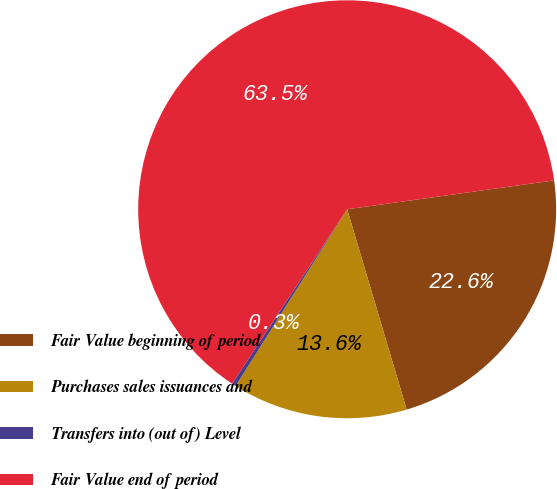Convert chart. <chart><loc_0><loc_0><loc_500><loc_500><pie_chart><fcel>Fair Value beginning of period<fcel>Purchases sales issuances and<fcel>Transfers into (out of) Level<fcel>Fair Value end of period<nl><fcel>22.61%<fcel>13.56%<fcel>0.32%<fcel>63.51%<nl></chart> 